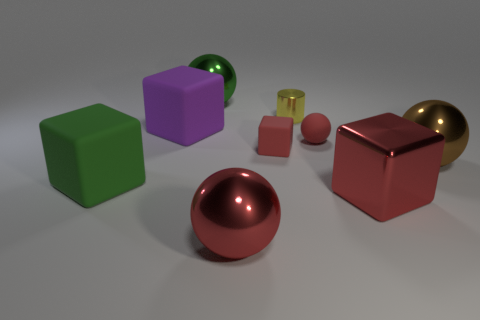There is a sphere to the right of the big red shiny thing that is behind the big red metal thing that is left of the tiny red block; what is its color? The sphere located to the right of the aforementioned red objects is copper-colored, exhibiting a metallic sheen that is indicative of a polished copper surface. Its hue is characterized by a warm, reddish-brown tone that differentiates it from the vibrant red of the nearby objects. 